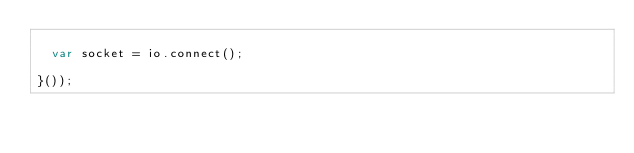Convert code to text. <code><loc_0><loc_0><loc_500><loc_500><_JavaScript_>
  var socket = io.connect();

}());
</code> 